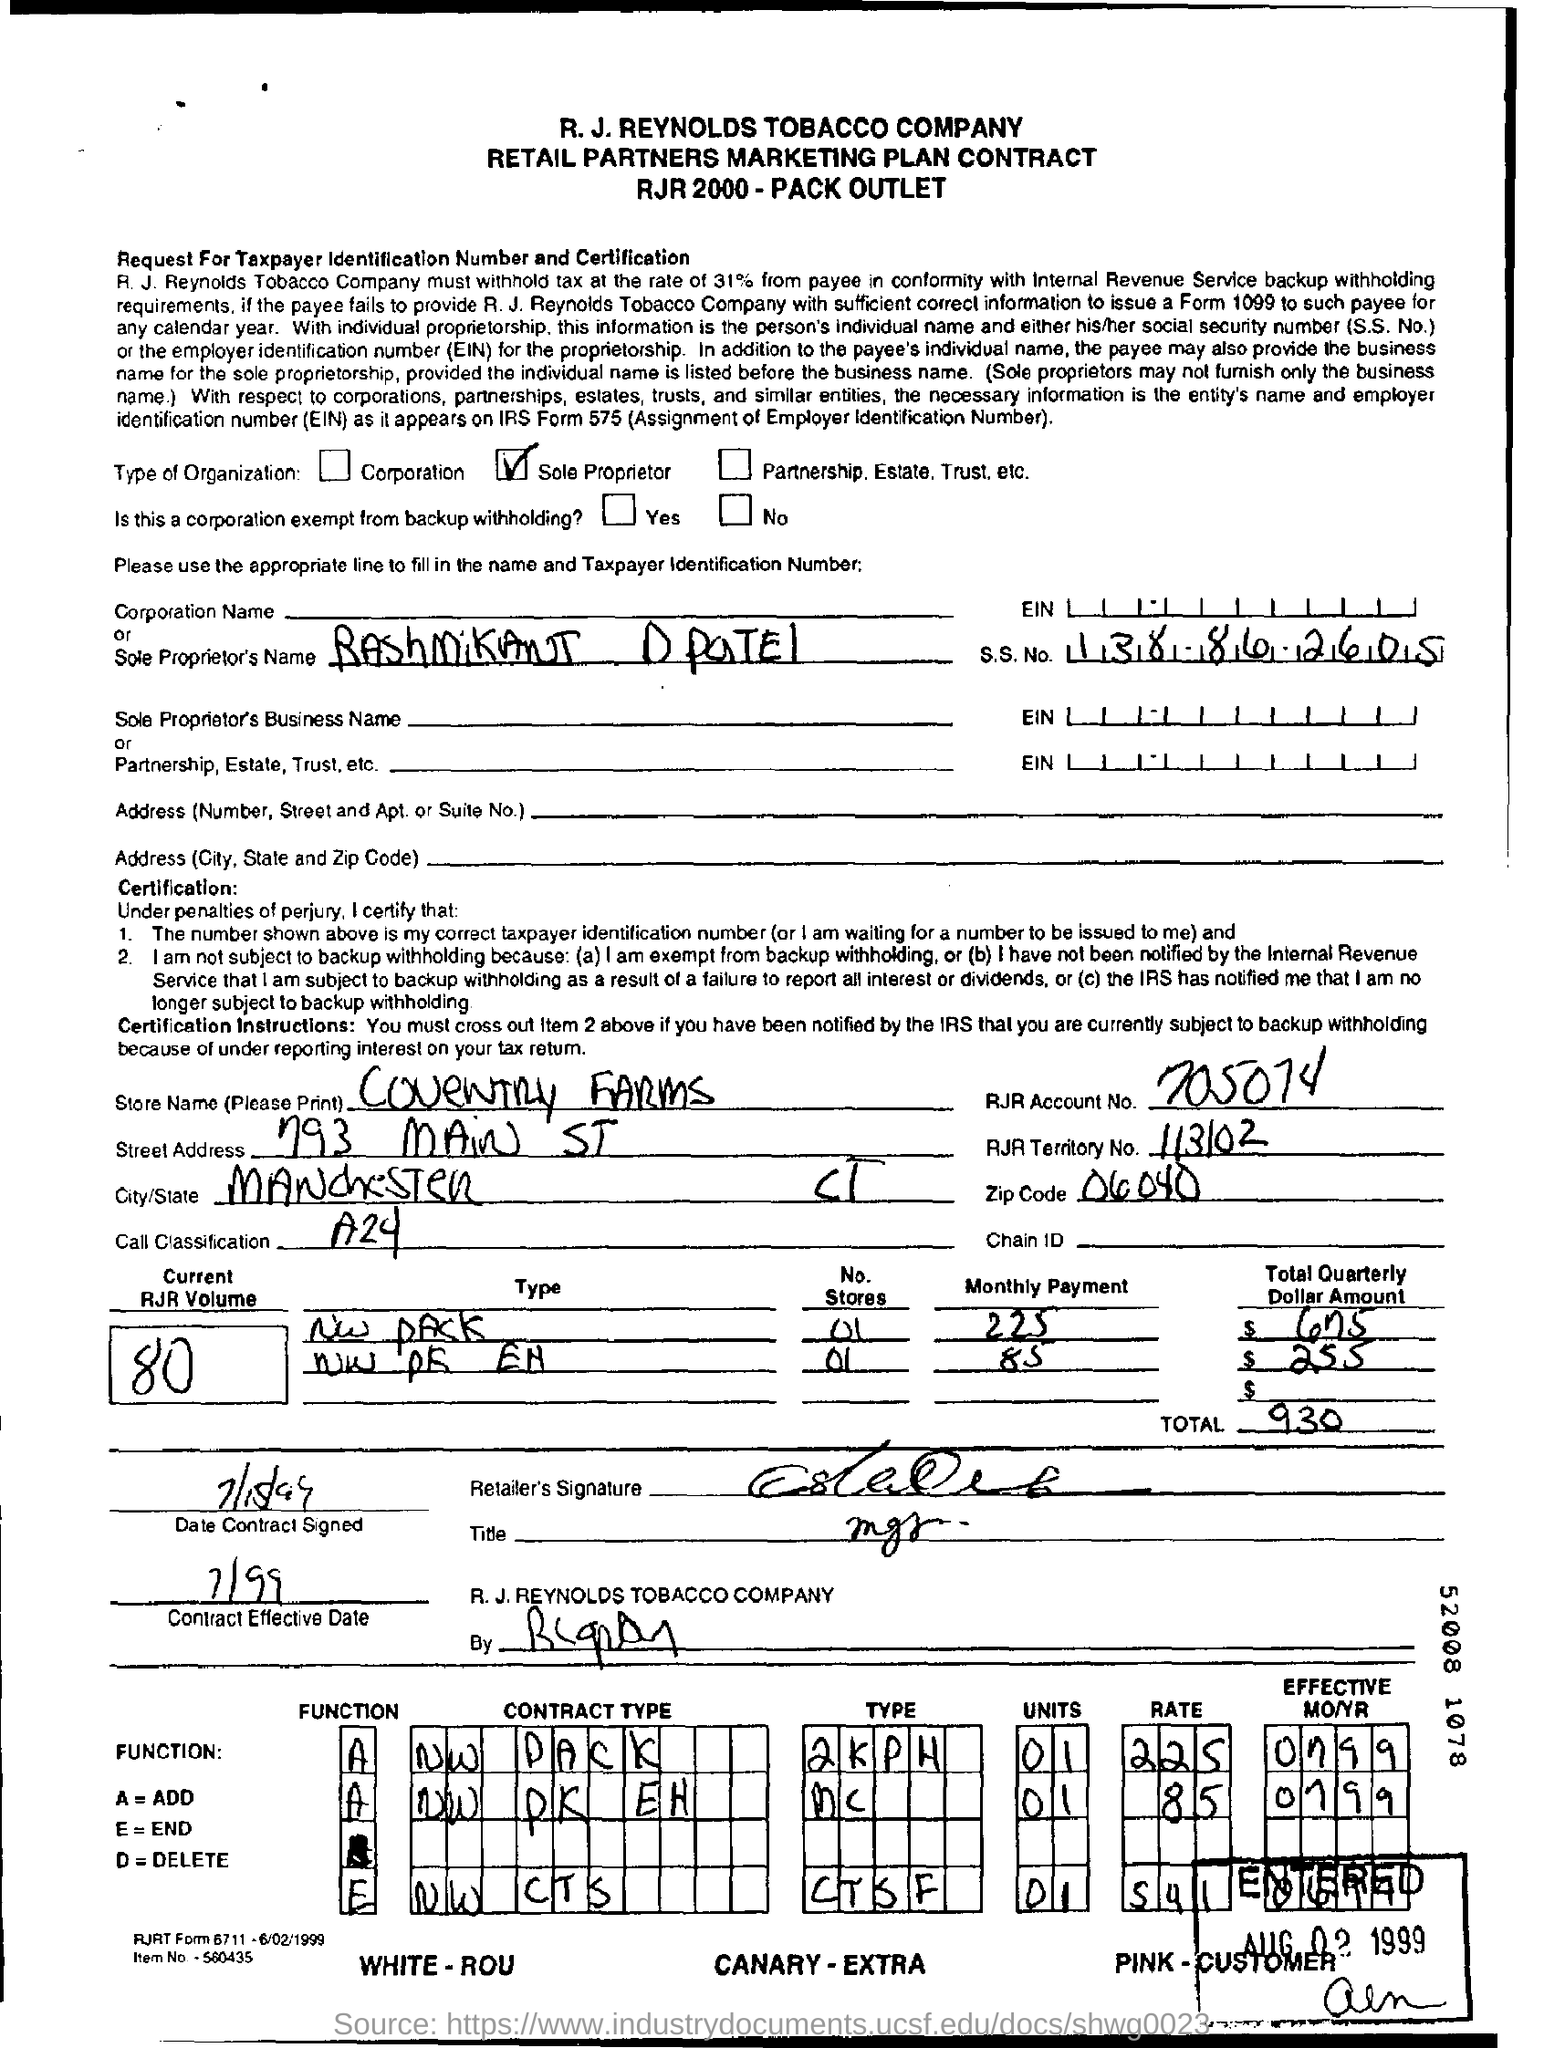Indicate a few pertinent items in this graphic. What is A= ?" is a question asking for an explanation or definition of the variable A=. "add" is a noun phrase. The total is 930. The SSN is 138-86-2605. The current volume number is 80. The street address of Coventry Farms is 793 Main Street. 